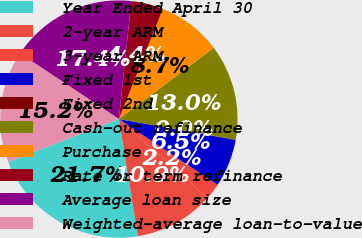Convert chart to OTSL. <chart><loc_0><loc_0><loc_500><loc_500><pie_chart><fcel>Year Ended April 30<fcel>2-year ARM<fcel>3-year ARM<fcel>Fixed 1st<fcel>Fixed 2nd<fcel>Cash-out refinance<fcel>Purchase<fcel>Rate or term refinance<fcel>Average loan size<fcel>Weighted-average loan-to-value<nl><fcel>21.69%<fcel>10.87%<fcel>2.21%<fcel>6.54%<fcel>0.04%<fcel>13.03%<fcel>8.7%<fcel>4.37%<fcel>17.36%<fcel>15.2%<nl></chart> 